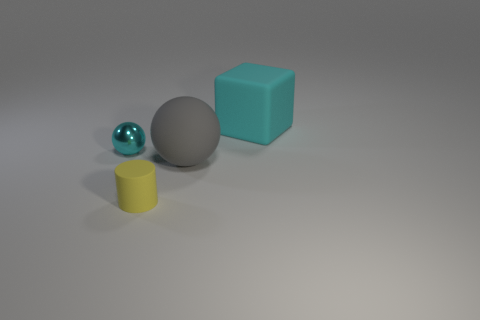How many other things are made of the same material as the cyan sphere?
Keep it short and to the point. 0. Is the material of the cyan thing behind the tiny shiny ball the same as the tiny cyan ball?
Make the answer very short. No. The yellow rubber thing has what shape?
Your answer should be compact. Cylinder. Is the number of large matte things on the right side of the big sphere greater than the number of small purple shiny cylinders?
Give a very brief answer. Yes. Is there any other thing that is the same shape as the tiny cyan thing?
Offer a very short reply. Yes. There is another small object that is the same shape as the gray matte object; what is its color?
Provide a short and direct response. Cyan. There is a thing that is left of the small cylinder; what shape is it?
Make the answer very short. Sphere. There is a metal object; are there any small cylinders in front of it?
Offer a terse response. Yes. The large cube that is the same material as the cylinder is what color?
Your answer should be compact. Cyan. There is a large rubber thing that is behind the large gray sphere; does it have the same color as the rubber object to the left of the large gray ball?
Your answer should be very brief. No. 